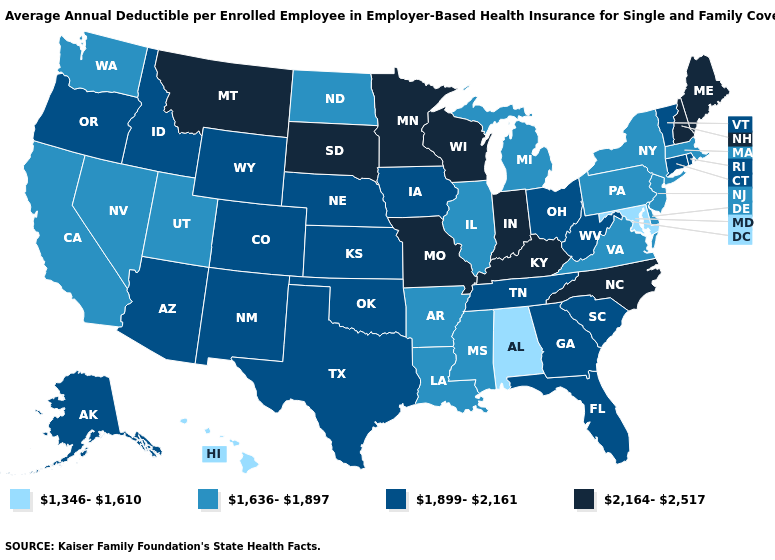Does Hawaii have the highest value in the USA?
Short answer required. No. Name the states that have a value in the range 2,164-2,517?
Concise answer only. Indiana, Kentucky, Maine, Minnesota, Missouri, Montana, New Hampshire, North Carolina, South Dakota, Wisconsin. Name the states that have a value in the range 1,899-2,161?
Be succinct. Alaska, Arizona, Colorado, Connecticut, Florida, Georgia, Idaho, Iowa, Kansas, Nebraska, New Mexico, Ohio, Oklahoma, Oregon, Rhode Island, South Carolina, Tennessee, Texas, Vermont, West Virginia, Wyoming. Name the states that have a value in the range 2,164-2,517?
Answer briefly. Indiana, Kentucky, Maine, Minnesota, Missouri, Montana, New Hampshire, North Carolina, South Dakota, Wisconsin. Name the states that have a value in the range 1,899-2,161?
Give a very brief answer. Alaska, Arizona, Colorado, Connecticut, Florida, Georgia, Idaho, Iowa, Kansas, Nebraska, New Mexico, Ohio, Oklahoma, Oregon, Rhode Island, South Carolina, Tennessee, Texas, Vermont, West Virginia, Wyoming. What is the highest value in states that border Wyoming?
Write a very short answer. 2,164-2,517. Which states have the highest value in the USA?
Give a very brief answer. Indiana, Kentucky, Maine, Minnesota, Missouri, Montana, New Hampshire, North Carolina, South Dakota, Wisconsin. Does Kansas have a lower value than Maine?
Concise answer only. Yes. What is the value of Nebraska?
Be succinct. 1,899-2,161. Does California have the highest value in the West?
Keep it brief. No. Does Illinois have the lowest value in the MidWest?
Write a very short answer. Yes. What is the value of Utah?
Quick response, please. 1,636-1,897. Among the states that border Indiana , which have the highest value?
Concise answer only. Kentucky. Does Montana have a higher value than South Carolina?
Short answer required. Yes. What is the highest value in the Northeast ?
Concise answer only. 2,164-2,517. 